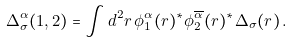Convert formula to latex. <formula><loc_0><loc_0><loc_500><loc_500>\Delta ^ { \alpha } _ { \sigma } ( 1 , 2 ) = \int d ^ { 2 } { r } \, \phi _ { 1 } ^ { \alpha } ( { r } ) ^ { * } \phi _ { 2 } ^ { \overline { \alpha } } ( { r } ) ^ { * } \Delta _ { \sigma } ( { r } ) \, .</formula> 